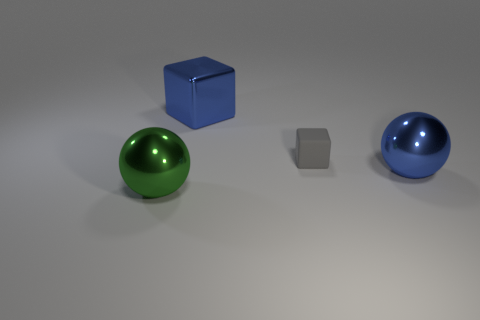What is the shape of the big metallic object that is on the left side of the blue block behind the large shiny object on the right side of the gray rubber thing?
Make the answer very short. Sphere. What number of large blue things have the same material as the small block?
Make the answer very short. 0. What number of green objects are in front of the big object that is to the right of the metallic block?
Offer a terse response. 1. What number of gray things are there?
Your answer should be compact. 1. Is the material of the large green thing the same as the cube that is on the right side of the metallic block?
Your answer should be compact. No. Is the color of the metal sphere that is right of the green object the same as the large metal cube?
Make the answer very short. Yes. What is the thing that is left of the gray matte thing and in front of the gray rubber cube made of?
Keep it short and to the point. Metal. What is the size of the blue metal block?
Your response must be concise. Large. Do the large block and the metallic object that is right of the shiny block have the same color?
Your answer should be very brief. Yes. What number of other objects are the same color as the large cube?
Provide a short and direct response. 1. 